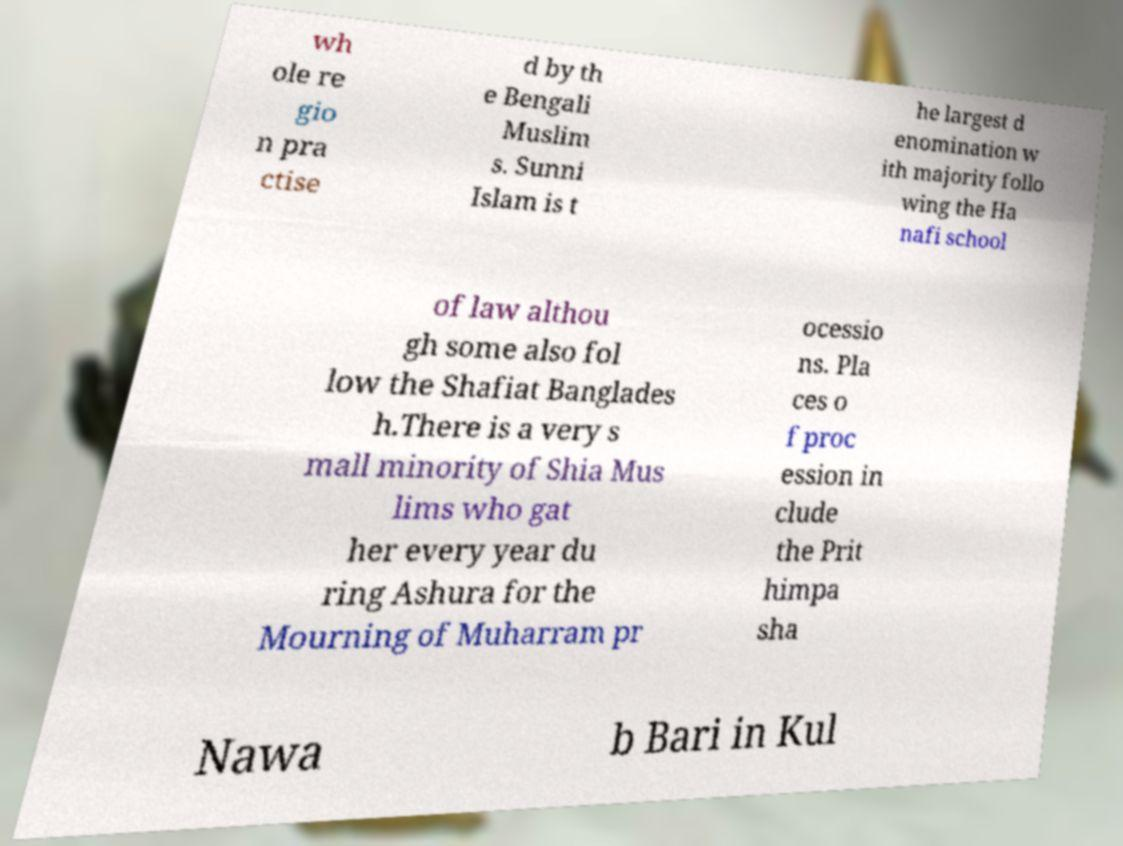Can you accurately transcribe the text from the provided image for me? wh ole re gio n pra ctise d by th e Bengali Muslim s. Sunni Islam is t he largest d enomination w ith majority follo wing the Ha nafi school of law althou gh some also fol low the Shafiat Banglades h.There is a very s mall minority of Shia Mus lims who gat her every year du ring Ashura for the Mourning of Muharram pr ocessio ns. Pla ces o f proc ession in clude the Prit himpa sha Nawa b Bari in Kul 